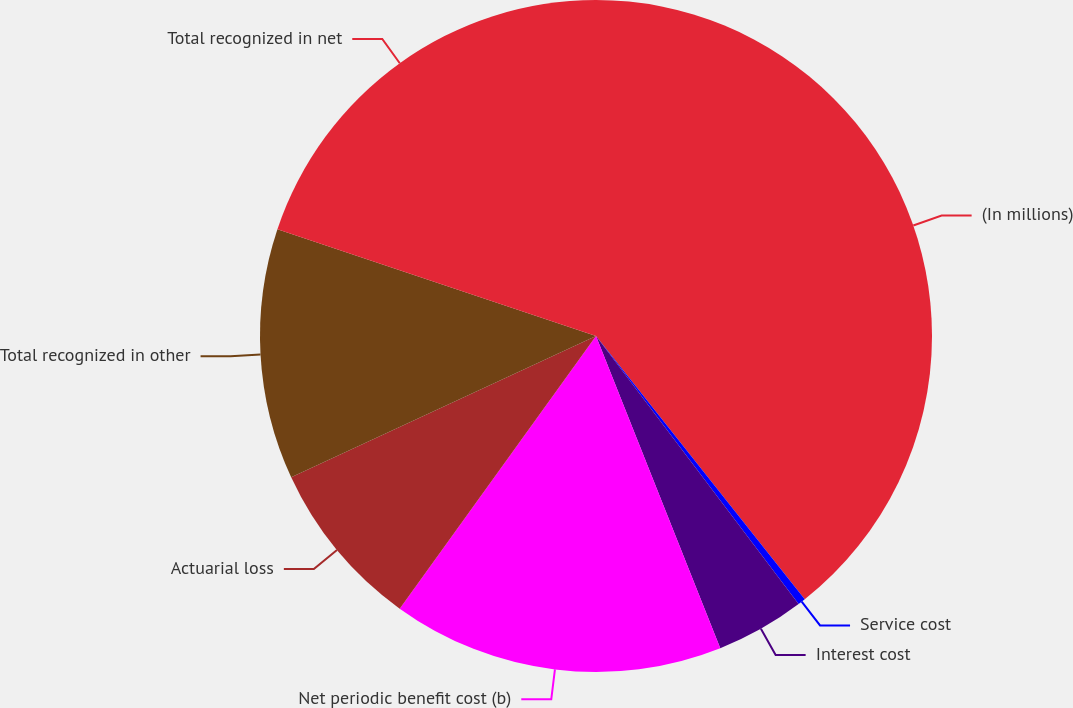<chart> <loc_0><loc_0><loc_500><loc_500><pie_chart><fcel>(In millions)<fcel>Service cost<fcel>Interest cost<fcel>Net periodic benefit cost (b)<fcel>Actuarial loss<fcel>Total recognized in other<fcel>Total recognized in net<nl><fcel>39.33%<fcel>0.37%<fcel>4.27%<fcel>15.96%<fcel>8.16%<fcel>12.06%<fcel>19.85%<nl></chart> 